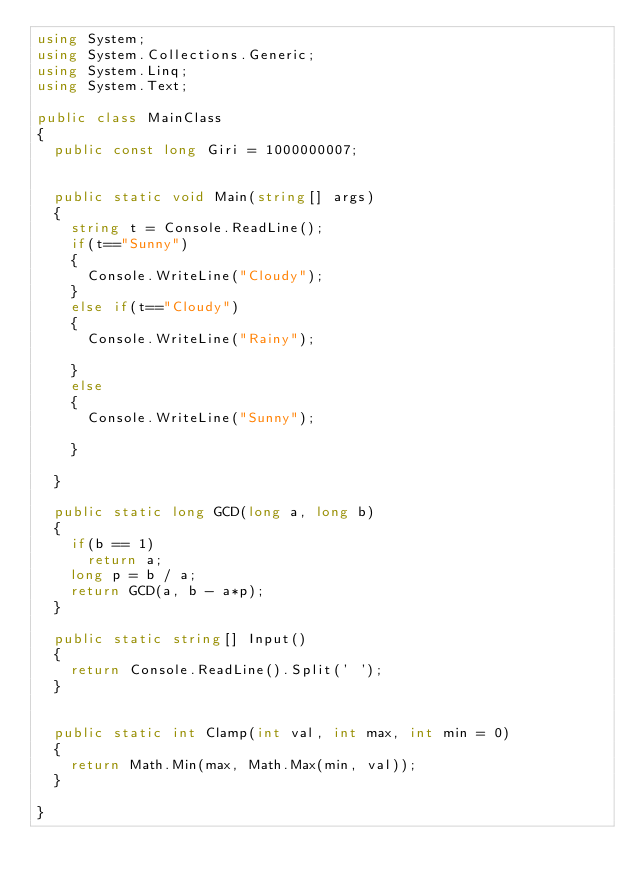Convert code to text. <code><loc_0><loc_0><loc_500><loc_500><_C#_>using System;
using System.Collections.Generic;
using System.Linq;
using System.Text;

public class MainClass
{
	public const long Giri = 1000000007;

	
	public static void Main(string[] args)
	{
		string t = Console.ReadLine();
		if(t=="Sunny")
		{
			Console.WriteLine("Cloudy");
		}
		else if(t=="Cloudy")
		{
			Console.WriteLine("Rainy");
		
		}
		else
		{
			Console.WriteLine("Sunny");
		
		}
		
	}
	
	public static long GCD(long a, long b)
	{
		if(b == 1)
			return a;
		long p = b / a;
		return GCD(a, b - a*p);
	}
	
	public static string[] Input()
	{
		return Console.ReadLine().Split(' ');
	}

	
	public static int Clamp(int val, int max, int min = 0)
	{
		return Math.Min(max, Math.Max(min, val));
	}

}

</code> 